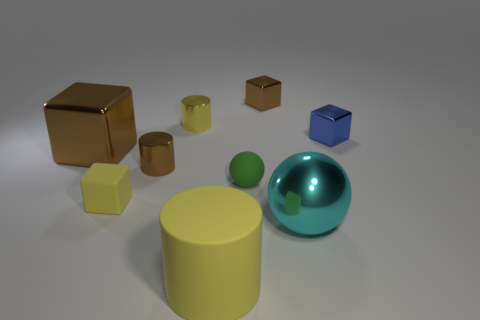What shape is the tiny brown object in front of the blue metal thing?
Offer a very short reply. Cylinder. What material is the object in front of the large shiny object on the right side of the tiny brown metallic object that is behind the small blue metallic cube?
Offer a terse response. Rubber. How many other objects are the same size as the yellow metal cylinder?
Make the answer very short. 5. There is another object that is the same shape as the large cyan metallic object; what is it made of?
Offer a very short reply. Rubber. What is the color of the large metallic ball?
Your answer should be compact. Cyan. What color is the big shiny object behind the small block that is to the left of the big yellow thing?
Keep it short and to the point. Brown. There is a small rubber sphere; is its color the same as the large metallic thing to the right of the large yellow thing?
Provide a short and direct response. No. What number of cyan objects are left of the yellow cylinder in front of the sphere that is to the left of the large sphere?
Offer a very short reply. 0. There is a shiny sphere; are there any brown cylinders in front of it?
Make the answer very short. No. Are there any other things that are the same color as the big rubber thing?
Your answer should be compact. Yes. 